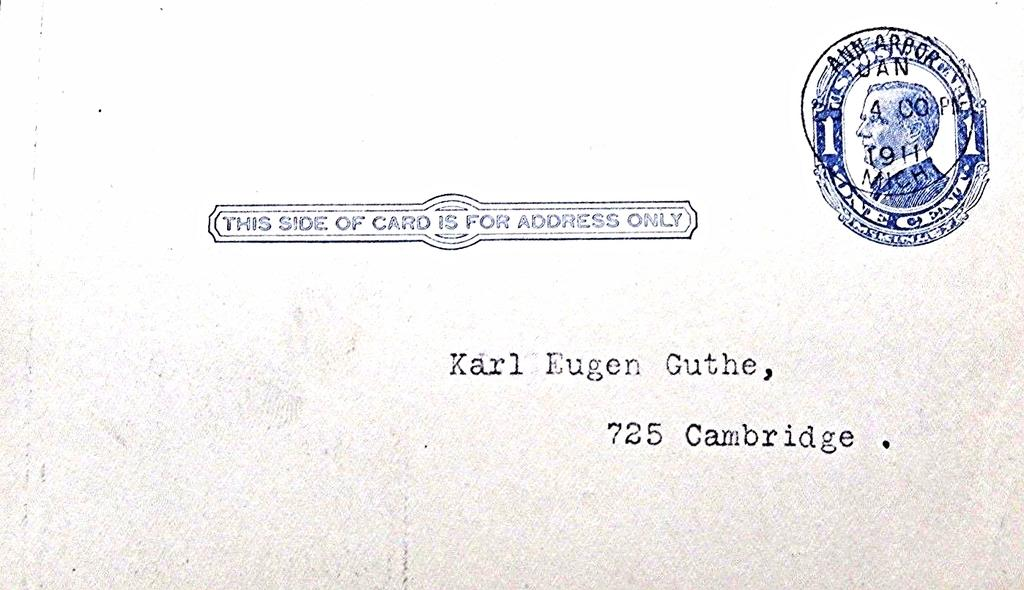<image>
Present a compact description of the photo's key features. A letter addressed to Karl Eugen Guthe in Cambridge. 